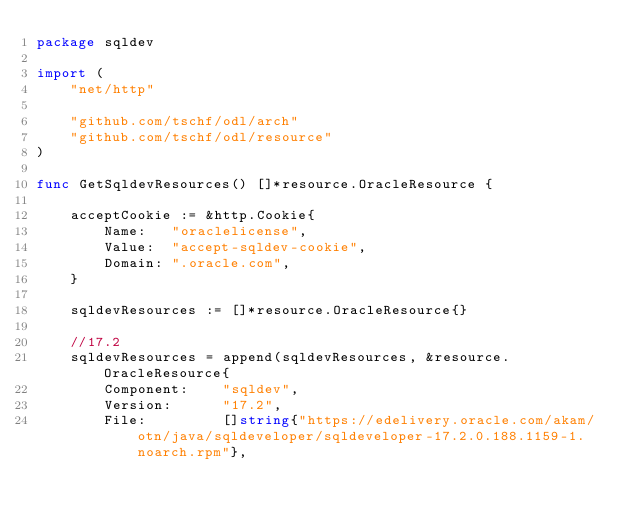<code> <loc_0><loc_0><loc_500><loc_500><_Go_>package sqldev

import (
	"net/http"

	"github.com/tschf/odl/arch"
	"github.com/tschf/odl/resource"
)

func GetSqldevResources() []*resource.OracleResource {

	acceptCookie := &http.Cookie{
		Name:   "oraclelicense",
		Value:  "accept-sqldev-cookie",
		Domain: ".oracle.com",
	}

	sqldevResources := []*resource.OracleResource{}

	//17.2
	sqldevResources = append(sqldevResources, &resource.OracleResource{
		Component:    "sqldev",
		Version:      "17.2",
		File:         []string{"https://edelivery.oracle.com/akam/otn/java/sqldeveloper/sqldeveloper-17.2.0.188.1159-1.noarch.rpm"},</code> 